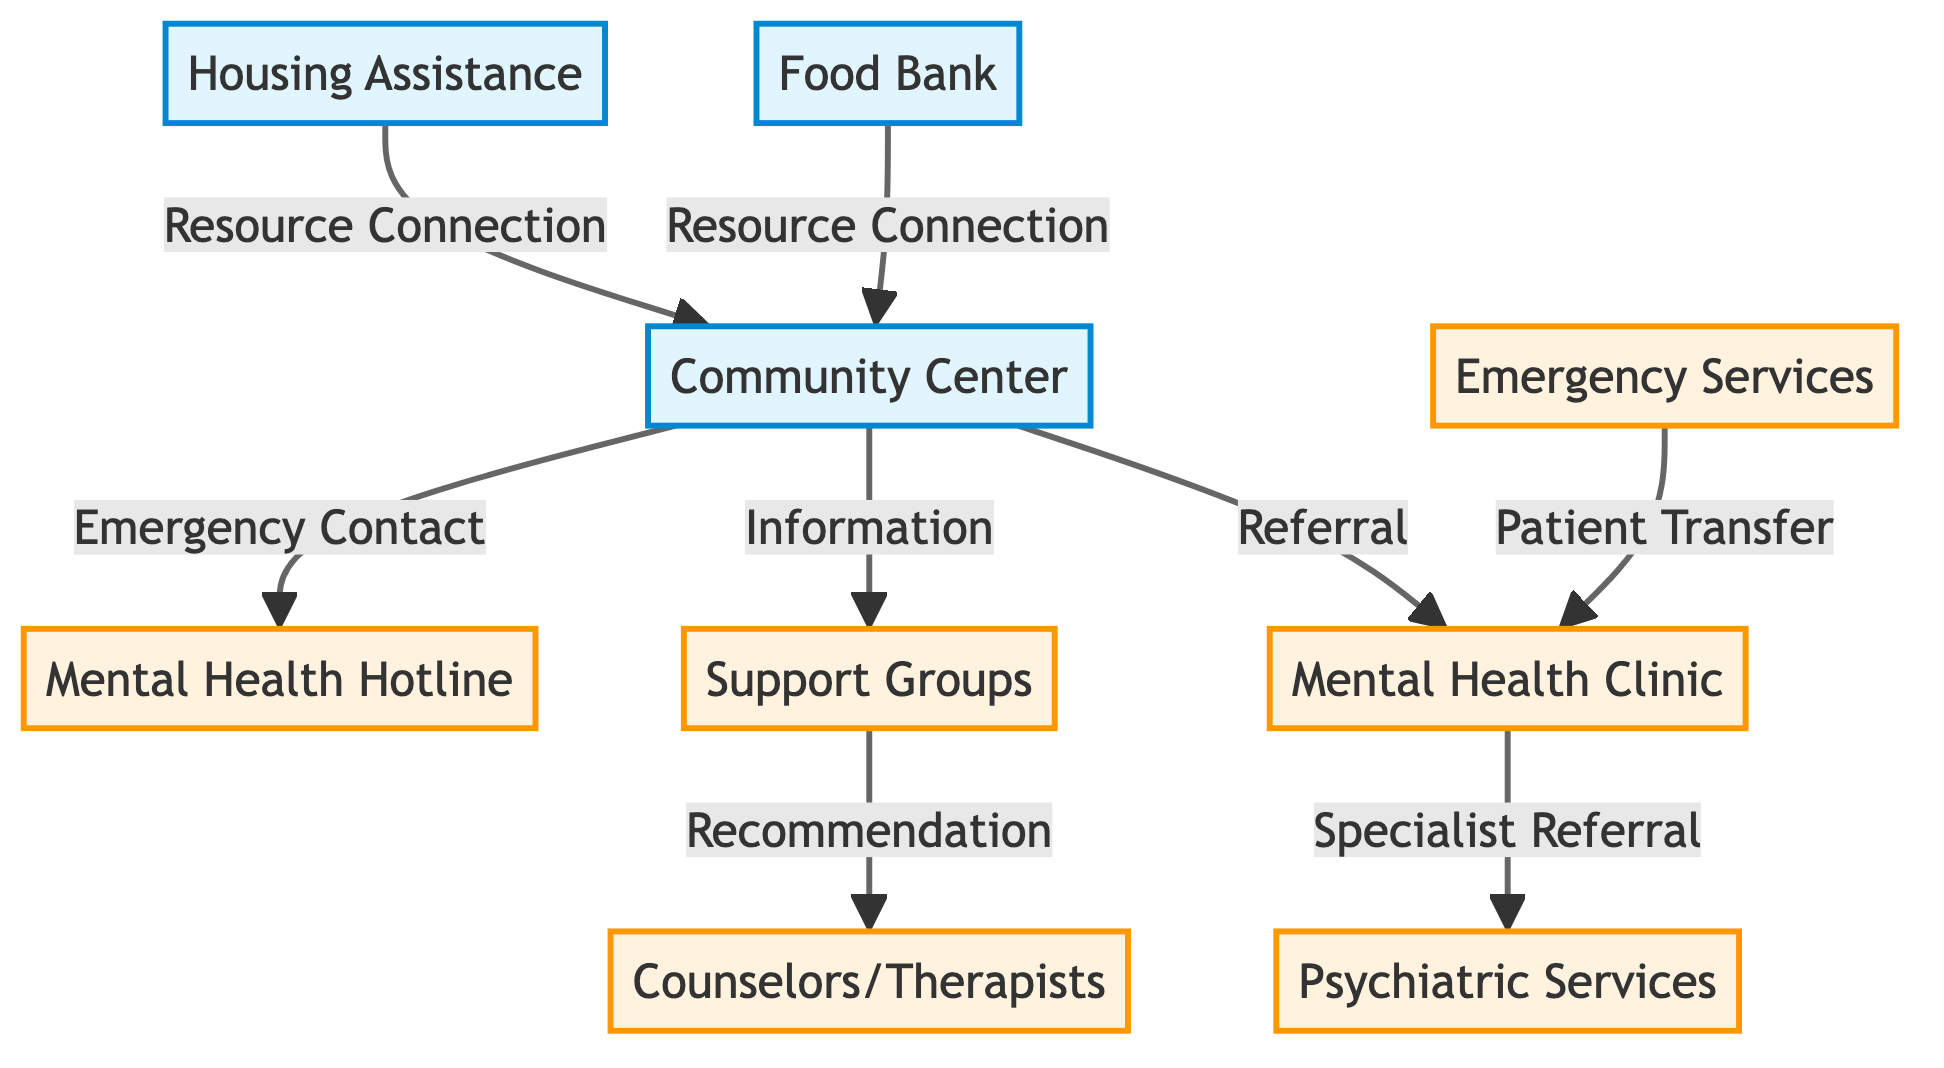What resource is connected to the Community Center? The Community Center is connected to the Food Bank through a Resource Connection.
Answer: Food Bank How many services are listed in the diagram? Count the services in the diagram, which are Mental Health Clinic, Support Groups, Mental Health Hotline, Counselors/Therapists, Psychiatric Services, and Emergency Services, totaling six services.
Answer: 6 What type of connection exists between Support Groups and Counselors/Therapists? Support Groups recommend clients to Counselors/Therapists through a Recommendation connection.
Answer: Recommendation Which resource provides information about Support Groups? The Community Center provides information related to Support Groups.
Answer: Community Center If someone needs emergency assistance, who should they contact based on the diagram? The diagram indicates that individuals in emergency situations should contact the Mental Health Hotline as an Emergency Contact option from the Community Center.
Answer: Mental Health Hotline What type of service does the Mental Health Clinic provide a referral to? The Mental Health Clinic specializes in referrals for Psychiatric Services.
Answer: Psychiatric Services What connections are made from the Community Center to external resources? The Community Center is connected to the Food Bank and Housing Assistance through Resource Connections.
Answer: Food Bank and Housing Assistance How are Emergency Services and the Mental Health Clinic related in the diagram? Emergency Services are connected to the Mental Health Clinic through a Patient Transfer relationship, indicating a direct link for critical situations.
Answer: Patient Transfer Which service is a first step for someone seeking mental health support after visiting a Community Center? After visiting the Community Center, the first step would typically be to attend Support Groups, as they are linked by an Information connection.
Answer: Support Groups 